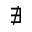<formula> <loc_0><loc_0><loc_500><loc_500>\nexists</formula> 